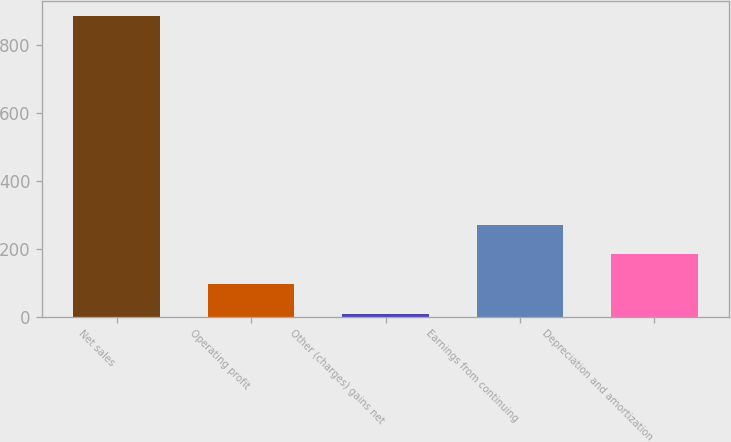Convert chart to OTSL. <chart><loc_0><loc_0><loc_500><loc_500><bar_chart><fcel>Net sales<fcel>Operating profit<fcel>Other (charges) gains net<fcel>Earnings from continuing<fcel>Depreciation and amortization<nl><fcel>887<fcel>95.9<fcel>8<fcel>271.7<fcel>183.8<nl></chart> 